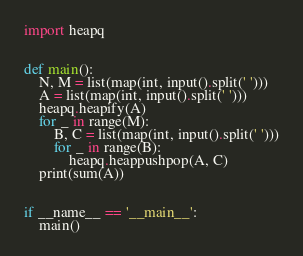<code> <loc_0><loc_0><loc_500><loc_500><_Python_>import heapq


def main():
    N, M = list(map(int, input().split(' ')))
    A = list(map(int, input().split(' ')))
    heapq.heapify(A)
    for _ in range(M):
        B, C = list(map(int, input().split(' ')))
        for _ in range(B):
            heapq.heappushpop(A, C)
    print(sum(A))


if __name__ == '__main__':
    main()</code> 